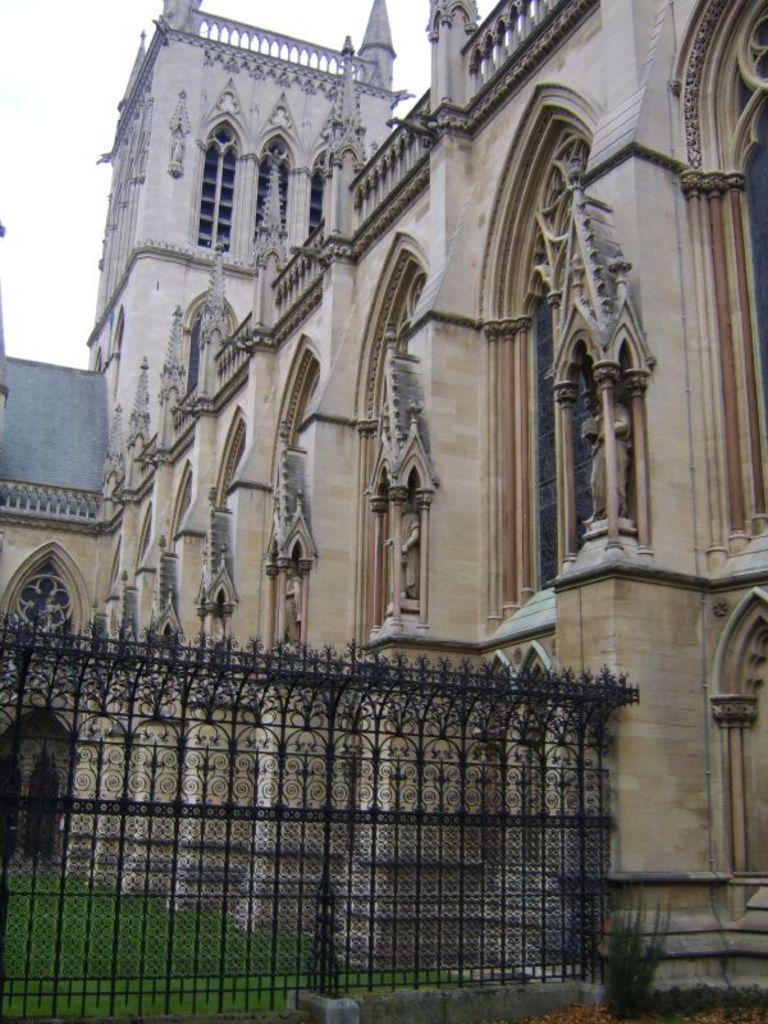How would you summarize this image in a sentence or two? In this image we can see a building, a metal railing, grass and the sky in the background. 